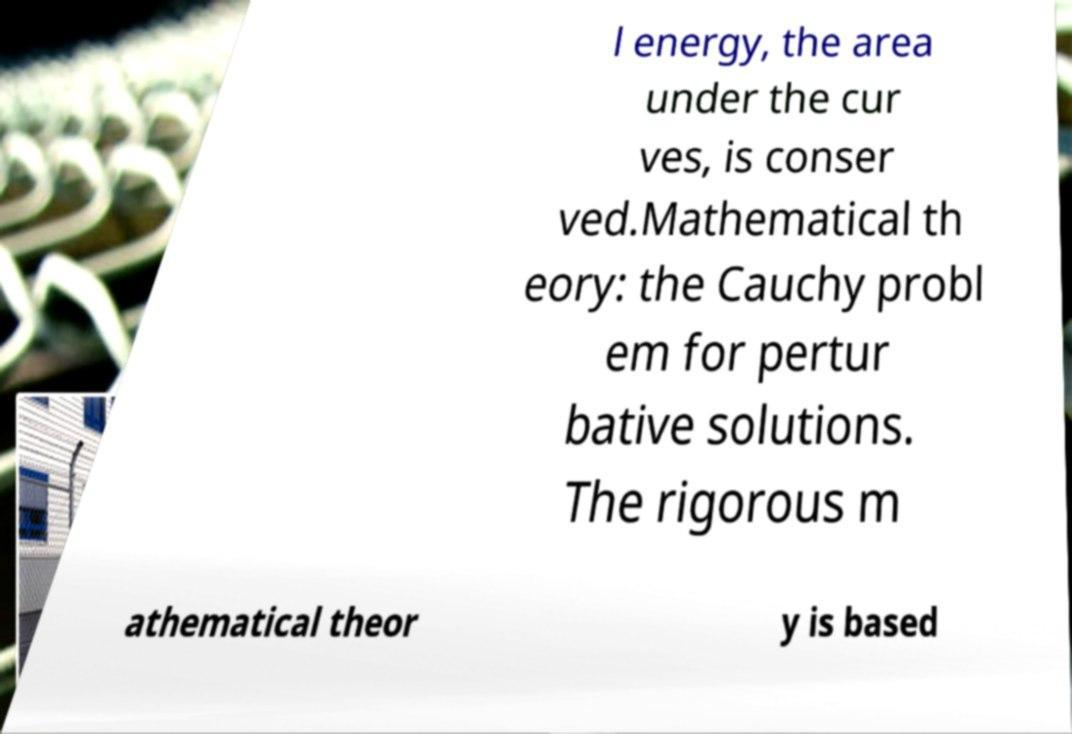Please identify and transcribe the text found in this image. l energy, the area under the cur ves, is conser ved.Mathematical th eory: the Cauchy probl em for pertur bative solutions. The rigorous m athematical theor y is based 